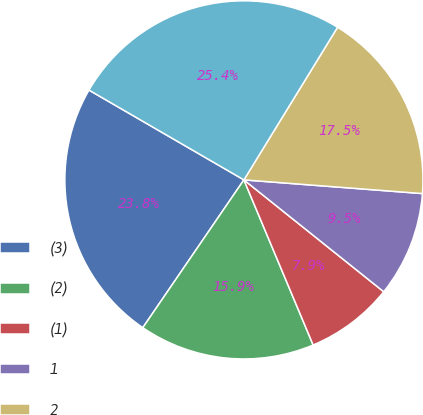<chart> <loc_0><loc_0><loc_500><loc_500><pie_chart><fcel>(3)<fcel>(2)<fcel>(1)<fcel>1<fcel>2<fcel>3<nl><fcel>23.81%<fcel>15.87%<fcel>7.94%<fcel>9.52%<fcel>17.46%<fcel>25.4%<nl></chart> 